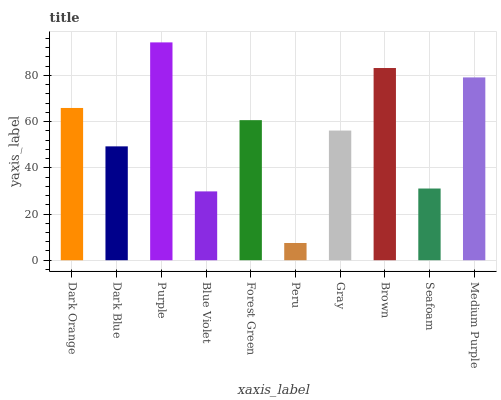Is Dark Blue the minimum?
Answer yes or no. No. Is Dark Blue the maximum?
Answer yes or no. No. Is Dark Orange greater than Dark Blue?
Answer yes or no. Yes. Is Dark Blue less than Dark Orange?
Answer yes or no. Yes. Is Dark Blue greater than Dark Orange?
Answer yes or no. No. Is Dark Orange less than Dark Blue?
Answer yes or no. No. Is Forest Green the high median?
Answer yes or no. Yes. Is Gray the low median?
Answer yes or no. Yes. Is Gray the high median?
Answer yes or no. No. Is Blue Violet the low median?
Answer yes or no. No. 